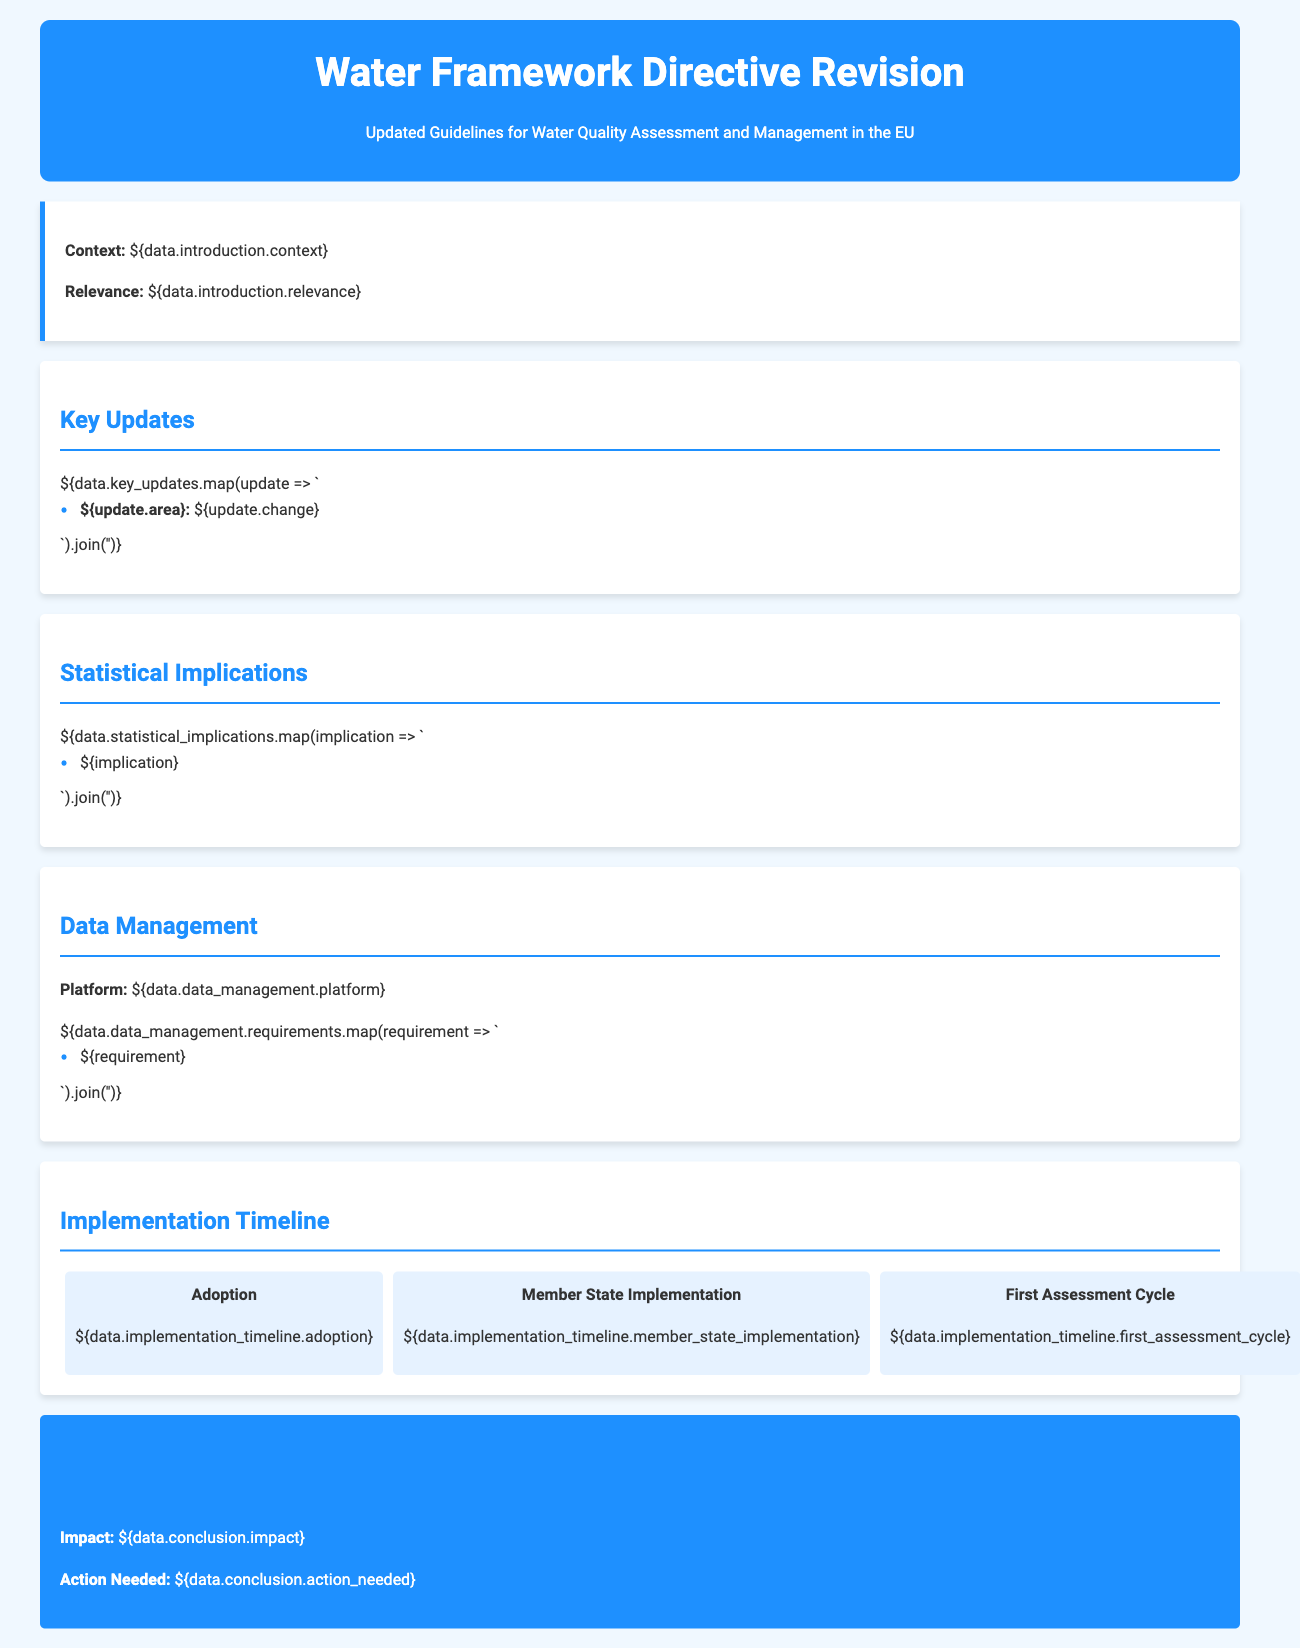What is the title of the document? The title of the document is stated prominently in the header section.
Answer: Water Framework Directive Revision What does the adoption timeline indicate? This is outlined in the implementation timeline section, showing when adoption will occur.
Answer: ${data.implementation_timeline.adoption} Which platform is used for data management? This is specified in the data management section as the platform utilized for managing data.
Answer: ${data.data_management.platform} What are the key areas that received updates? The key updates list specific areas that have undergone changes in the new guidelines.
Answer: ${data.key_updates.map(update => update.area).join(', ')} How many assessment cycles are planned? The document likely outlines this in the implementation timeline.
Answer: 1 What is the primary impact stated in the conclusion? This impact is highlighted in the conclusion section providing insight into the document's focus.
Answer: ${data.conclusion.impact} What statistical implications are mentioned? These are addressed directly under the statistical implications section of the document.
Answer: ${data.statistical_implications.join(', ')} What action is needed according to the conclusion? This actionable requirement is expressed in the conclusion outlining necessary steps.
Answer: ${data.conclusion.action_needed} 